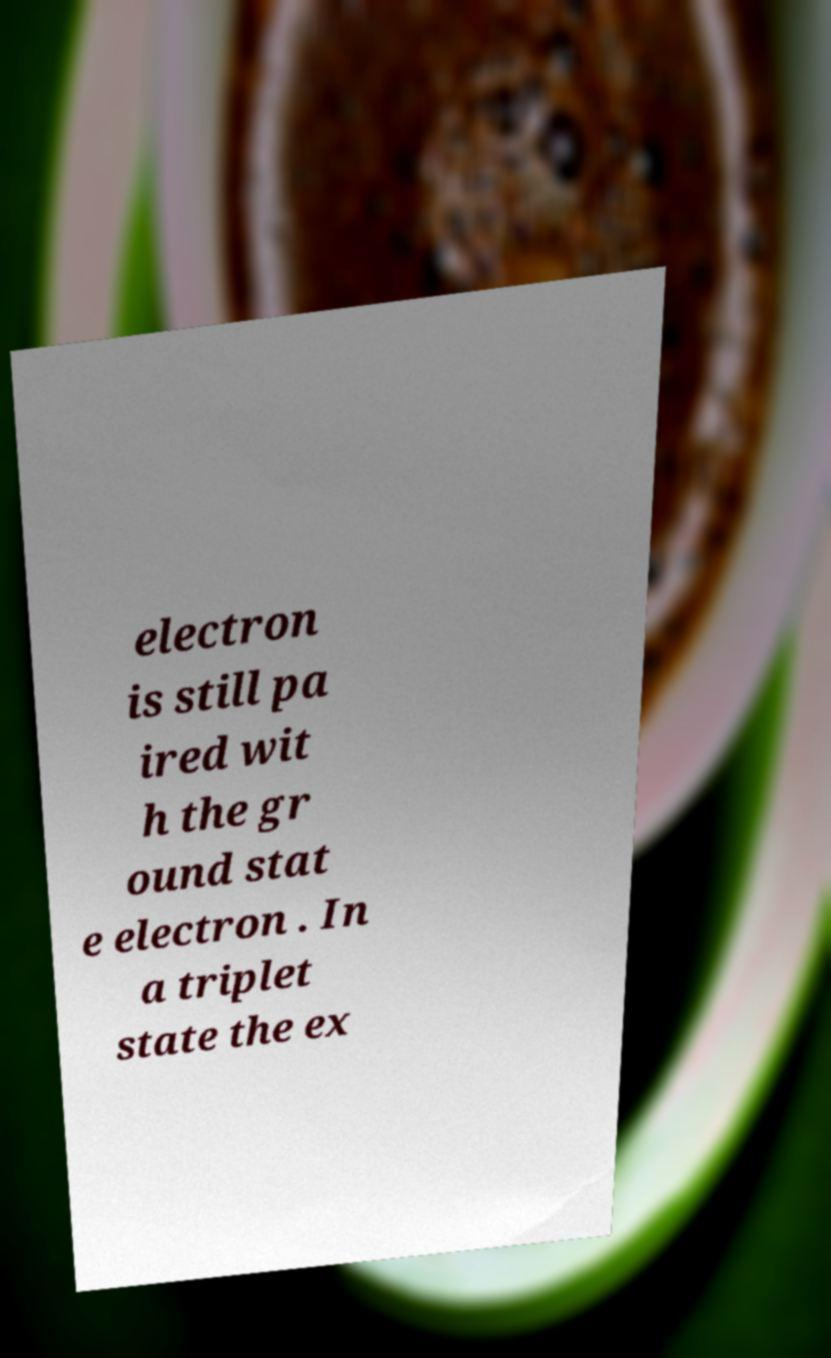Can you read and provide the text displayed in the image?This photo seems to have some interesting text. Can you extract and type it out for me? electron is still pa ired wit h the gr ound stat e electron . In a triplet state the ex 